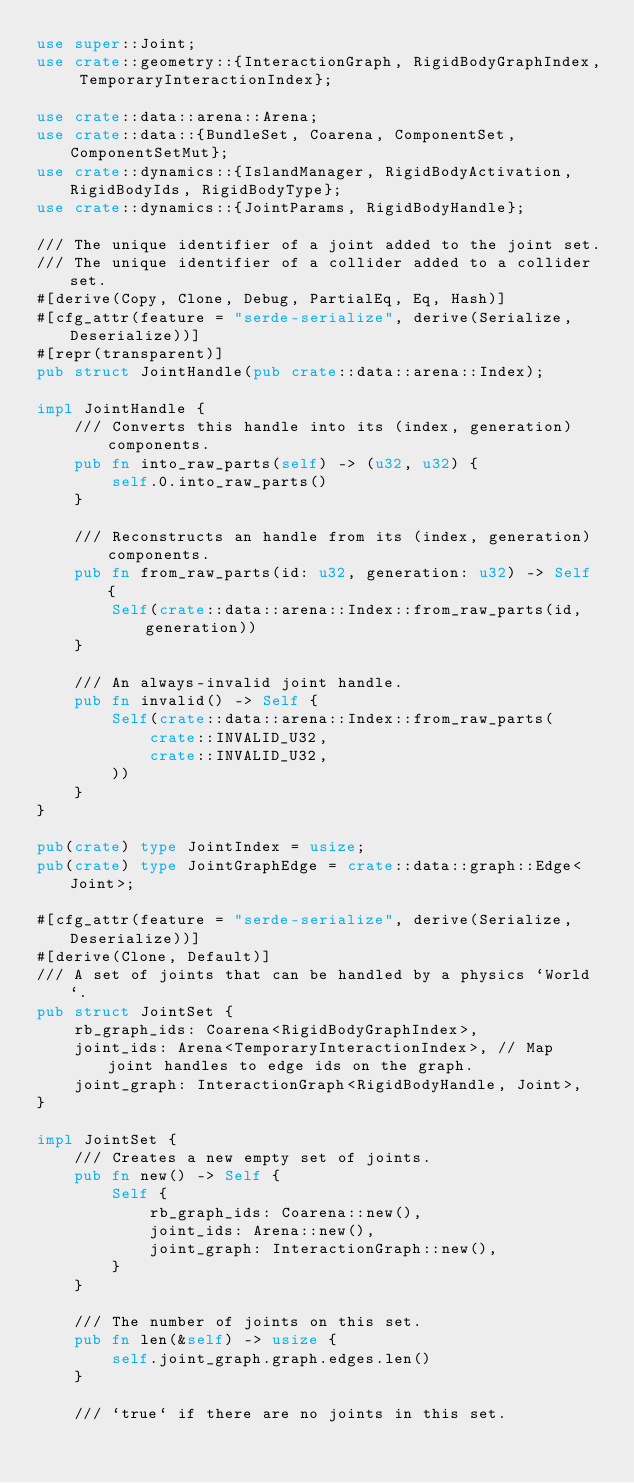<code> <loc_0><loc_0><loc_500><loc_500><_Rust_>use super::Joint;
use crate::geometry::{InteractionGraph, RigidBodyGraphIndex, TemporaryInteractionIndex};

use crate::data::arena::Arena;
use crate::data::{BundleSet, Coarena, ComponentSet, ComponentSetMut};
use crate::dynamics::{IslandManager, RigidBodyActivation, RigidBodyIds, RigidBodyType};
use crate::dynamics::{JointParams, RigidBodyHandle};

/// The unique identifier of a joint added to the joint set.
/// The unique identifier of a collider added to a collider set.
#[derive(Copy, Clone, Debug, PartialEq, Eq, Hash)]
#[cfg_attr(feature = "serde-serialize", derive(Serialize, Deserialize))]
#[repr(transparent)]
pub struct JointHandle(pub crate::data::arena::Index);

impl JointHandle {
    /// Converts this handle into its (index, generation) components.
    pub fn into_raw_parts(self) -> (u32, u32) {
        self.0.into_raw_parts()
    }

    /// Reconstructs an handle from its (index, generation) components.
    pub fn from_raw_parts(id: u32, generation: u32) -> Self {
        Self(crate::data::arena::Index::from_raw_parts(id, generation))
    }

    /// An always-invalid joint handle.
    pub fn invalid() -> Self {
        Self(crate::data::arena::Index::from_raw_parts(
            crate::INVALID_U32,
            crate::INVALID_U32,
        ))
    }
}

pub(crate) type JointIndex = usize;
pub(crate) type JointGraphEdge = crate::data::graph::Edge<Joint>;

#[cfg_attr(feature = "serde-serialize", derive(Serialize, Deserialize))]
#[derive(Clone, Default)]
/// A set of joints that can be handled by a physics `World`.
pub struct JointSet {
    rb_graph_ids: Coarena<RigidBodyGraphIndex>,
    joint_ids: Arena<TemporaryInteractionIndex>, // Map joint handles to edge ids on the graph.
    joint_graph: InteractionGraph<RigidBodyHandle, Joint>,
}

impl JointSet {
    /// Creates a new empty set of joints.
    pub fn new() -> Self {
        Self {
            rb_graph_ids: Coarena::new(),
            joint_ids: Arena::new(),
            joint_graph: InteractionGraph::new(),
        }
    }

    /// The number of joints on this set.
    pub fn len(&self) -> usize {
        self.joint_graph.graph.edges.len()
    }

    /// `true` if there are no joints in this set.</code> 